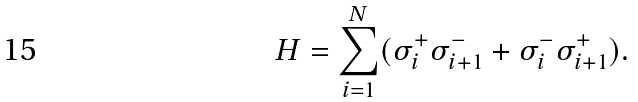<formula> <loc_0><loc_0><loc_500><loc_500>H = \sum _ { i = 1 } ^ { N } ( \sigma ^ { + } _ { i } \sigma ^ { - } _ { i + 1 } + \sigma ^ { - } _ { i } \sigma ^ { + } _ { i + 1 } ) .</formula> 